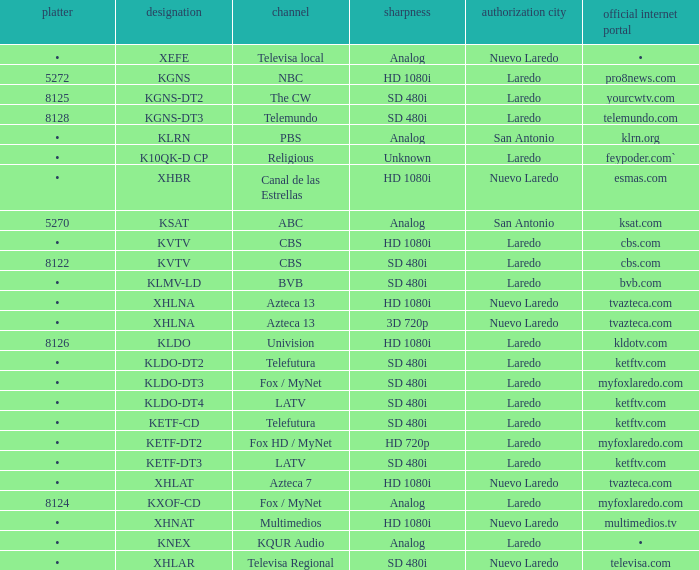Name the city of license with resolution of sd 480i and official website of telemundo.com Laredo. 